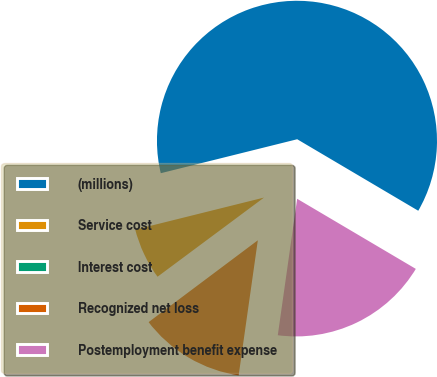Convert chart. <chart><loc_0><loc_0><loc_500><loc_500><pie_chart><fcel>(millions)<fcel>Service cost<fcel>Interest cost<fcel>Recognized net loss<fcel>Postemployment benefit expense<nl><fcel>62.37%<fcel>6.29%<fcel>0.06%<fcel>12.52%<fcel>18.75%<nl></chart> 